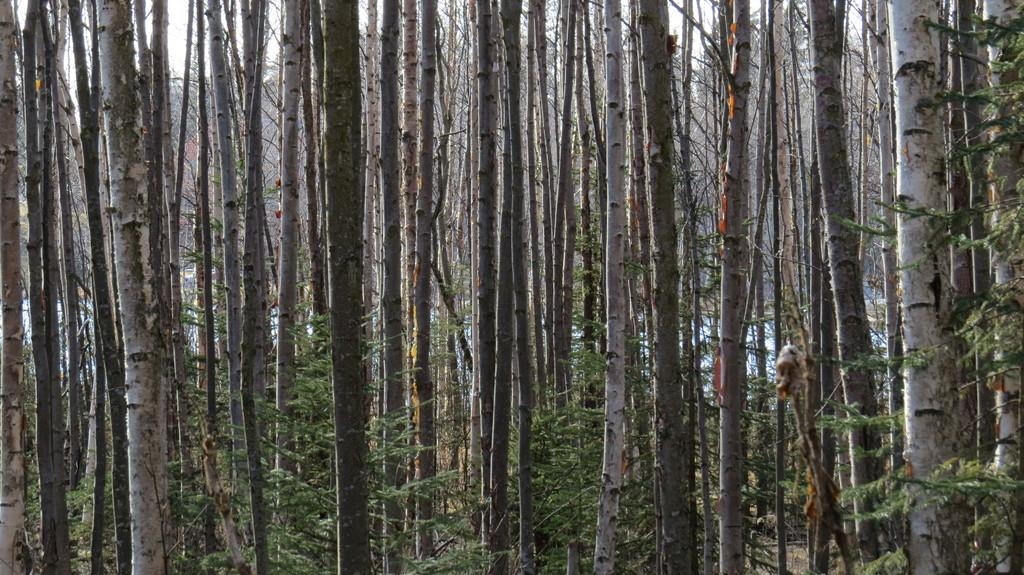What type of vegetation can be seen in the image? There are trees in the image. Can you describe the trees in the image? The provided facts do not give specific details about the trees, so we cannot describe them further. What is the value of the crack in the class depicted in the image? There is no crack or class present in the image; it only features trees. 